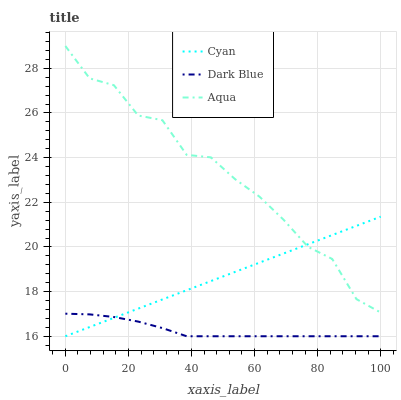Does Dark Blue have the minimum area under the curve?
Answer yes or no. Yes. Does Aqua have the maximum area under the curve?
Answer yes or no. Yes. Does Aqua have the minimum area under the curve?
Answer yes or no. No. Does Dark Blue have the maximum area under the curve?
Answer yes or no. No. Is Cyan the smoothest?
Answer yes or no. Yes. Is Aqua the roughest?
Answer yes or no. Yes. Is Dark Blue the smoothest?
Answer yes or no. No. Is Dark Blue the roughest?
Answer yes or no. No. Does Cyan have the lowest value?
Answer yes or no. Yes. Does Aqua have the lowest value?
Answer yes or no. No. Does Aqua have the highest value?
Answer yes or no. Yes. Does Dark Blue have the highest value?
Answer yes or no. No. Is Dark Blue less than Aqua?
Answer yes or no. Yes. Is Aqua greater than Dark Blue?
Answer yes or no. Yes. Does Aqua intersect Cyan?
Answer yes or no. Yes. Is Aqua less than Cyan?
Answer yes or no. No. Is Aqua greater than Cyan?
Answer yes or no. No. Does Dark Blue intersect Aqua?
Answer yes or no. No. 